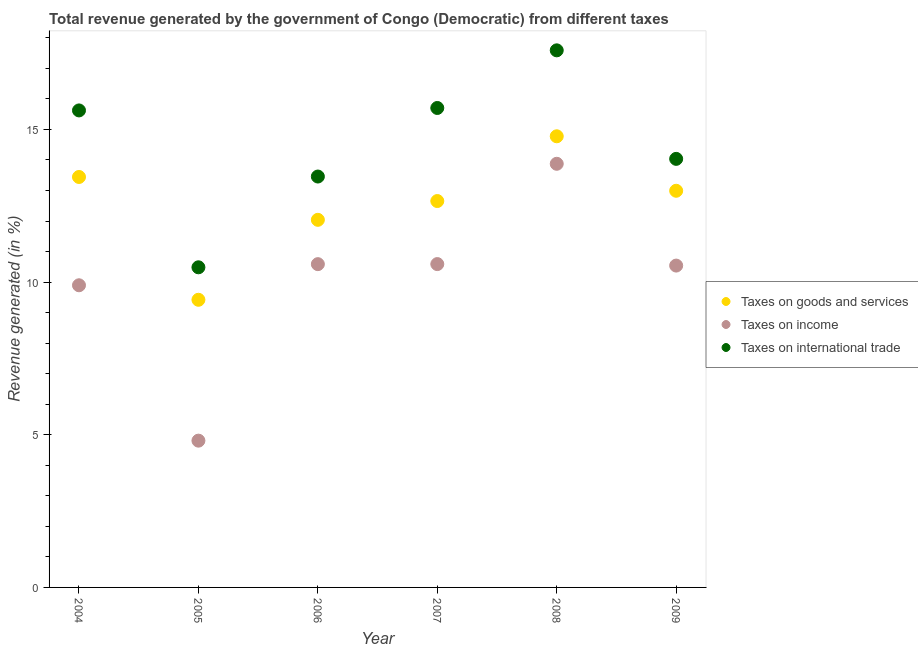What is the percentage of revenue generated by taxes on goods and services in 2009?
Give a very brief answer. 12.99. Across all years, what is the maximum percentage of revenue generated by taxes on goods and services?
Offer a very short reply. 14.78. Across all years, what is the minimum percentage of revenue generated by taxes on income?
Your response must be concise. 4.81. In which year was the percentage of revenue generated by taxes on goods and services maximum?
Offer a very short reply. 2008. In which year was the percentage of revenue generated by tax on international trade minimum?
Give a very brief answer. 2005. What is the total percentage of revenue generated by taxes on income in the graph?
Keep it short and to the point. 60.3. What is the difference between the percentage of revenue generated by taxes on income in 2004 and that in 2005?
Offer a terse response. 5.09. What is the difference between the percentage of revenue generated by taxes on goods and services in 2008 and the percentage of revenue generated by tax on international trade in 2004?
Make the answer very short. -0.85. What is the average percentage of revenue generated by taxes on income per year?
Give a very brief answer. 10.05. In the year 2004, what is the difference between the percentage of revenue generated by taxes on income and percentage of revenue generated by tax on international trade?
Offer a very short reply. -5.73. What is the ratio of the percentage of revenue generated by tax on international trade in 2004 to that in 2009?
Provide a short and direct response. 1.11. Is the percentage of revenue generated by tax on international trade in 2004 less than that in 2008?
Your answer should be very brief. Yes. Is the difference between the percentage of revenue generated by taxes on income in 2005 and 2008 greater than the difference between the percentage of revenue generated by taxes on goods and services in 2005 and 2008?
Your response must be concise. No. What is the difference between the highest and the second highest percentage of revenue generated by tax on international trade?
Your answer should be compact. 1.89. What is the difference between the highest and the lowest percentage of revenue generated by taxes on goods and services?
Provide a short and direct response. 5.35. In how many years, is the percentage of revenue generated by taxes on income greater than the average percentage of revenue generated by taxes on income taken over all years?
Your response must be concise. 4. Is the percentage of revenue generated by taxes on income strictly less than the percentage of revenue generated by taxes on goods and services over the years?
Give a very brief answer. Yes. How many dotlines are there?
Your response must be concise. 3. How many years are there in the graph?
Give a very brief answer. 6. What is the difference between two consecutive major ticks on the Y-axis?
Provide a succinct answer. 5. Are the values on the major ticks of Y-axis written in scientific E-notation?
Your answer should be very brief. No. Does the graph contain any zero values?
Offer a terse response. No. How many legend labels are there?
Offer a terse response. 3. What is the title of the graph?
Your answer should be compact. Total revenue generated by the government of Congo (Democratic) from different taxes. Does "Social Protection and Labor" appear as one of the legend labels in the graph?
Ensure brevity in your answer.  No. What is the label or title of the Y-axis?
Provide a succinct answer. Revenue generated (in %). What is the Revenue generated (in %) in Taxes on goods and services in 2004?
Your answer should be compact. 13.44. What is the Revenue generated (in %) of Taxes on income in 2004?
Give a very brief answer. 9.9. What is the Revenue generated (in %) in Taxes on international trade in 2004?
Provide a succinct answer. 15.62. What is the Revenue generated (in %) of Taxes on goods and services in 2005?
Your response must be concise. 9.42. What is the Revenue generated (in %) in Taxes on income in 2005?
Keep it short and to the point. 4.81. What is the Revenue generated (in %) of Taxes on international trade in 2005?
Provide a short and direct response. 10.48. What is the Revenue generated (in %) in Taxes on goods and services in 2006?
Make the answer very short. 12.04. What is the Revenue generated (in %) in Taxes on income in 2006?
Provide a short and direct response. 10.59. What is the Revenue generated (in %) of Taxes on international trade in 2006?
Ensure brevity in your answer.  13.46. What is the Revenue generated (in %) in Taxes on goods and services in 2007?
Your answer should be compact. 12.66. What is the Revenue generated (in %) in Taxes on income in 2007?
Your answer should be compact. 10.59. What is the Revenue generated (in %) in Taxes on international trade in 2007?
Ensure brevity in your answer.  15.7. What is the Revenue generated (in %) of Taxes on goods and services in 2008?
Ensure brevity in your answer.  14.78. What is the Revenue generated (in %) of Taxes on income in 2008?
Your answer should be very brief. 13.88. What is the Revenue generated (in %) of Taxes on international trade in 2008?
Provide a succinct answer. 17.59. What is the Revenue generated (in %) in Taxes on goods and services in 2009?
Keep it short and to the point. 12.99. What is the Revenue generated (in %) of Taxes on income in 2009?
Offer a terse response. 10.54. What is the Revenue generated (in %) of Taxes on international trade in 2009?
Give a very brief answer. 14.04. Across all years, what is the maximum Revenue generated (in %) of Taxes on goods and services?
Give a very brief answer. 14.78. Across all years, what is the maximum Revenue generated (in %) of Taxes on income?
Offer a terse response. 13.88. Across all years, what is the maximum Revenue generated (in %) in Taxes on international trade?
Your response must be concise. 17.59. Across all years, what is the minimum Revenue generated (in %) of Taxes on goods and services?
Give a very brief answer. 9.42. Across all years, what is the minimum Revenue generated (in %) of Taxes on income?
Your response must be concise. 4.81. Across all years, what is the minimum Revenue generated (in %) in Taxes on international trade?
Offer a very short reply. 10.48. What is the total Revenue generated (in %) of Taxes on goods and services in the graph?
Make the answer very short. 75.33. What is the total Revenue generated (in %) of Taxes on income in the graph?
Your answer should be very brief. 60.3. What is the total Revenue generated (in %) in Taxes on international trade in the graph?
Provide a succinct answer. 86.9. What is the difference between the Revenue generated (in %) in Taxes on goods and services in 2004 and that in 2005?
Make the answer very short. 4.02. What is the difference between the Revenue generated (in %) in Taxes on income in 2004 and that in 2005?
Your answer should be compact. 5.09. What is the difference between the Revenue generated (in %) of Taxes on international trade in 2004 and that in 2005?
Your response must be concise. 5.14. What is the difference between the Revenue generated (in %) in Taxes on goods and services in 2004 and that in 2006?
Your answer should be very brief. 1.4. What is the difference between the Revenue generated (in %) of Taxes on income in 2004 and that in 2006?
Offer a terse response. -0.69. What is the difference between the Revenue generated (in %) of Taxes on international trade in 2004 and that in 2006?
Your response must be concise. 2.17. What is the difference between the Revenue generated (in %) in Taxes on goods and services in 2004 and that in 2007?
Your response must be concise. 0.79. What is the difference between the Revenue generated (in %) of Taxes on income in 2004 and that in 2007?
Keep it short and to the point. -0.69. What is the difference between the Revenue generated (in %) of Taxes on international trade in 2004 and that in 2007?
Provide a succinct answer. -0.08. What is the difference between the Revenue generated (in %) of Taxes on goods and services in 2004 and that in 2008?
Provide a short and direct response. -1.33. What is the difference between the Revenue generated (in %) of Taxes on income in 2004 and that in 2008?
Offer a terse response. -3.98. What is the difference between the Revenue generated (in %) in Taxes on international trade in 2004 and that in 2008?
Keep it short and to the point. -1.97. What is the difference between the Revenue generated (in %) of Taxes on goods and services in 2004 and that in 2009?
Your answer should be very brief. 0.45. What is the difference between the Revenue generated (in %) in Taxes on income in 2004 and that in 2009?
Offer a terse response. -0.64. What is the difference between the Revenue generated (in %) of Taxes on international trade in 2004 and that in 2009?
Your response must be concise. 1.59. What is the difference between the Revenue generated (in %) in Taxes on goods and services in 2005 and that in 2006?
Your answer should be compact. -2.62. What is the difference between the Revenue generated (in %) in Taxes on income in 2005 and that in 2006?
Keep it short and to the point. -5.78. What is the difference between the Revenue generated (in %) of Taxes on international trade in 2005 and that in 2006?
Keep it short and to the point. -2.97. What is the difference between the Revenue generated (in %) in Taxes on goods and services in 2005 and that in 2007?
Provide a succinct answer. -3.23. What is the difference between the Revenue generated (in %) of Taxes on income in 2005 and that in 2007?
Your answer should be very brief. -5.78. What is the difference between the Revenue generated (in %) in Taxes on international trade in 2005 and that in 2007?
Keep it short and to the point. -5.22. What is the difference between the Revenue generated (in %) in Taxes on goods and services in 2005 and that in 2008?
Offer a terse response. -5.35. What is the difference between the Revenue generated (in %) of Taxes on income in 2005 and that in 2008?
Your response must be concise. -9.07. What is the difference between the Revenue generated (in %) of Taxes on international trade in 2005 and that in 2008?
Offer a very short reply. -7.11. What is the difference between the Revenue generated (in %) in Taxes on goods and services in 2005 and that in 2009?
Offer a very short reply. -3.57. What is the difference between the Revenue generated (in %) of Taxes on income in 2005 and that in 2009?
Your answer should be compact. -5.73. What is the difference between the Revenue generated (in %) of Taxes on international trade in 2005 and that in 2009?
Make the answer very short. -3.55. What is the difference between the Revenue generated (in %) of Taxes on goods and services in 2006 and that in 2007?
Give a very brief answer. -0.62. What is the difference between the Revenue generated (in %) in Taxes on income in 2006 and that in 2007?
Offer a very short reply. -0. What is the difference between the Revenue generated (in %) of Taxes on international trade in 2006 and that in 2007?
Provide a succinct answer. -2.25. What is the difference between the Revenue generated (in %) of Taxes on goods and services in 2006 and that in 2008?
Offer a terse response. -2.74. What is the difference between the Revenue generated (in %) in Taxes on income in 2006 and that in 2008?
Your response must be concise. -3.29. What is the difference between the Revenue generated (in %) of Taxes on international trade in 2006 and that in 2008?
Your answer should be compact. -4.13. What is the difference between the Revenue generated (in %) of Taxes on goods and services in 2006 and that in 2009?
Offer a terse response. -0.95. What is the difference between the Revenue generated (in %) of Taxes on income in 2006 and that in 2009?
Offer a terse response. 0.05. What is the difference between the Revenue generated (in %) in Taxes on international trade in 2006 and that in 2009?
Your answer should be compact. -0.58. What is the difference between the Revenue generated (in %) of Taxes on goods and services in 2007 and that in 2008?
Your response must be concise. -2.12. What is the difference between the Revenue generated (in %) in Taxes on income in 2007 and that in 2008?
Give a very brief answer. -3.28. What is the difference between the Revenue generated (in %) in Taxes on international trade in 2007 and that in 2008?
Give a very brief answer. -1.89. What is the difference between the Revenue generated (in %) of Taxes on goods and services in 2007 and that in 2009?
Your answer should be very brief. -0.34. What is the difference between the Revenue generated (in %) of Taxes on income in 2007 and that in 2009?
Give a very brief answer. 0.05. What is the difference between the Revenue generated (in %) in Taxes on international trade in 2007 and that in 2009?
Your answer should be compact. 1.67. What is the difference between the Revenue generated (in %) in Taxes on goods and services in 2008 and that in 2009?
Give a very brief answer. 1.78. What is the difference between the Revenue generated (in %) in Taxes on income in 2008 and that in 2009?
Give a very brief answer. 3.33. What is the difference between the Revenue generated (in %) in Taxes on international trade in 2008 and that in 2009?
Offer a terse response. 3.55. What is the difference between the Revenue generated (in %) in Taxes on goods and services in 2004 and the Revenue generated (in %) in Taxes on income in 2005?
Make the answer very short. 8.64. What is the difference between the Revenue generated (in %) in Taxes on goods and services in 2004 and the Revenue generated (in %) in Taxes on international trade in 2005?
Ensure brevity in your answer.  2.96. What is the difference between the Revenue generated (in %) in Taxes on income in 2004 and the Revenue generated (in %) in Taxes on international trade in 2005?
Ensure brevity in your answer.  -0.59. What is the difference between the Revenue generated (in %) in Taxes on goods and services in 2004 and the Revenue generated (in %) in Taxes on income in 2006?
Your response must be concise. 2.86. What is the difference between the Revenue generated (in %) of Taxes on goods and services in 2004 and the Revenue generated (in %) of Taxes on international trade in 2006?
Your answer should be very brief. -0.01. What is the difference between the Revenue generated (in %) of Taxes on income in 2004 and the Revenue generated (in %) of Taxes on international trade in 2006?
Give a very brief answer. -3.56. What is the difference between the Revenue generated (in %) of Taxes on goods and services in 2004 and the Revenue generated (in %) of Taxes on income in 2007?
Ensure brevity in your answer.  2.85. What is the difference between the Revenue generated (in %) in Taxes on goods and services in 2004 and the Revenue generated (in %) in Taxes on international trade in 2007?
Offer a very short reply. -2.26. What is the difference between the Revenue generated (in %) in Taxes on income in 2004 and the Revenue generated (in %) in Taxes on international trade in 2007?
Ensure brevity in your answer.  -5.81. What is the difference between the Revenue generated (in %) in Taxes on goods and services in 2004 and the Revenue generated (in %) in Taxes on income in 2008?
Give a very brief answer. -0.43. What is the difference between the Revenue generated (in %) of Taxes on goods and services in 2004 and the Revenue generated (in %) of Taxes on international trade in 2008?
Provide a succinct answer. -4.15. What is the difference between the Revenue generated (in %) in Taxes on income in 2004 and the Revenue generated (in %) in Taxes on international trade in 2008?
Make the answer very short. -7.69. What is the difference between the Revenue generated (in %) in Taxes on goods and services in 2004 and the Revenue generated (in %) in Taxes on income in 2009?
Provide a short and direct response. 2.9. What is the difference between the Revenue generated (in %) in Taxes on goods and services in 2004 and the Revenue generated (in %) in Taxes on international trade in 2009?
Your answer should be compact. -0.59. What is the difference between the Revenue generated (in %) of Taxes on income in 2004 and the Revenue generated (in %) of Taxes on international trade in 2009?
Provide a succinct answer. -4.14. What is the difference between the Revenue generated (in %) in Taxes on goods and services in 2005 and the Revenue generated (in %) in Taxes on income in 2006?
Provide a short and direct response. -1.17. What is the difference between the Revenue generated (in %) of Taxes on goods and services in 2005 and the Revenue generated (in %) of Taxes on international trade in 2006?
Offer a terse response. -4.04. What is the difference between the Revenue generated (in %) of Taxes on income in 2005 and the Revenue generated (in %) of Taxes on international trade in 2006?
Provide a short and direct response. -8.65. What is the difference between the Revenue generated (in %) of Taxes on goods and services in 2005 and the Revenue generated (in %) of Taxes on income in 2007?
Offer a very short reply. -1.17. What is the difference between the Revenue generated (in %) of Taxes on goods and services in 2005 and the Revenue generated (in %) of Taxes on international trade in 2007?
Your response must be concise. -6.28. What is the difference between the Revenue generated (in %) in Taxes on income in 2005 and the Revenue generated (in %) in Taxes on international trade in 2007?
Keep it short and to the point. -10.9. What is the difference between the Revenue generated (in %) of Taxes on goods and services in 2005 and the Revenue generated (in %) of Taxes on income in 2008?
Provide a short and direct response. -4.45. What is the difference between the Revenue generated (in %) of Taxes on goods and services in 2005 and the Revenue generated (in %) of Taxes on international trade in 2008?
Offer a terse response. -8.17. What is the difference between the Revenue generated (in %) of Taxes on income in 2005 and the Revenue generated (in %) of Taxes on international trade in 2008?
Make the answer very short. -12.78. What is the difference between the Revenue generated (in %) in Taxes on goods and services in 2005 and the Revenue generated (in %) in Taxes on income in 2009?
Provide a short and direct response. -1.12. What is the difference between the Revenue generated (in %) of Taxes on goods and services in 2005 and the Revenue generated (in %) of Taxes on international trade in 2009?
Your response must be concise. -4.62. What is the difference between the Revenue generated (in %) of Taxes on income in 2005 and the Revenue generated (in %) of Taxes on international trade in 2009?
Keep it short and to the point. -9.23. What is the difference between the Revenue generated (in %) in Taxes on goods and services in 2006 and the Revenue generated (in %) in Taxes on income in 2007?
Offer a very short reply. 1.45. What is the difference between the Revenue generated (in %) of Taxes on goods and services in 2006 and the Revenue generated (in %) of Taxes on international trade in 2007?
Offer a terse response. -3.66. What is the difference between the Revenue generated (in %) in Taxes on income in 2006 and the Revenue generated (in %) in Taxes on international trade in 2007?
Keep it short and to the point. -5.11. What is the difference between the Revenue generated (in %) in Taxes on goods and services in 2006 and the Revenue generated (in %) in Taxes on income in 2008?
Make the answer very short. -1.84. What is the difference between the Revenue generated (in %) in Taxes on goods and services in 2006 and the Revenue generated (in %) in Taxes on international trade in 2008?
Your answer should be compact. -5.55. What is the difference between the Revenue generated (in %) of Taxes on income in 2006 and the Revenue generated (in %) of Taxes on international trade in 2008?
Your answer should be very brief. -7. What is the difference between the Revenue generated (in %) in Taxes on goods and services in 2006 and the Revenue generated (in %) in Taxes on income in 2009?
Offer a terse response. 1.5. What is the difference between the Revenue generated (in %) of Taxes on goods and services in 2006 and the Revenue generated (in %) of Taxes on international trade in 2009?
Make the answer very short. -2. What is the difference between the Revenue generated (in %) of Taxes on income in 2006 and the Revenue generated (in %) of Taxes on international trade in 2009?
Keep it short and to the point. -3.45. What is the difference between the Revenue generated (in %) of Taxes on goods and services in 2007 and the Revenue generated (in %) of Taxes on income in 2008?
Ensure brevity in your answer.  -1.22. What is the difference between the Revenue generated (in %) of Taxes on goods and services in 2007 and the Revenue generated (in %) of Taxes on international trade in 2008?
Offer a terse response. -4.94. What is the difference between the Revenue generated (in %) in Taxes on income in 2007 and the Revenue generated (in %) in Taxes on international trade in 2008?
Your answer should be compact. -7. What is the difference between the Revenue generated (in %) of Taxes on goods and services in 2007 and the Revenue generated (in %) of Taxes on income in 2009?
Provide a succinct answer. 2.11. What is the difference between the Revenue generated (in %) of Taxes on goods and services in 2007 and the Revenue generated (in %) of Taxes on international trade in 2009?
Your response must be concise. -1.38. What is the difference between the Revenue generated (in %) in Taxes on income in 2007 and the Revenue generated (in %) in Taxes on international trade in 2009?
Your response must be concise. -3.45. What is the difference between the Revenue generated (in %) of Taxes on goods and services in 2008 and the Revenue generated (in %) of Taxes on income in 2009?
Your answer should be compact. 4.23. What is the difference between the Revenue generated (in %) of Taxes on goods and services in 2008 and the Revenue generated (in %) of Taxes on international trade in 2009?
Your answer should be compact. 0.74. What is the difference between the Revenue generated (in %) of Taxes on income in 2008 and the Revenue generated (in %) of Taxes on international trade in 2009?
Offer a very short reply. -0.16. What is the average Revenue generated (in %) in Taxes on goods and services per year?
Your answer should be compact. 12.55. What is the average Revenue generated (in %) in Taxes on income per year?
Your answer should be very brief. 10.05. What is the average Revenue generated (in %) of Taxes on international trade per year?
Your answer should be compact. 14.48. In the year 2004, what is the difference between the Revenue generated (in %) in Taxes on goods and services and Revenue generated (in %) in Taxes on income?
Your answer should be very brief. 3.55. In the year 2004, what is the difference between the Revenue generated (in %) in Taxes on goods and services and Revenue generated (in %) in Taxes on international trade?
Give a very brief answer. -2.18. In the year 2004, what is the difference between the Revenue generated (in %) in Taxes on income and Revenue generated (in %) in Taxes on international trade?
Offer a terse response. -5.73. In the year 2005, what is the difference between the Revenue generated (in %) of Taxes on goods and services and Revenue generated (in %) of Taxes on income?
Offer a terse response. 4.61. In the year 2005, what is the difference between the Revenue generated (in %) in Taxes on goods and services and Revenue generated (in %) in Taxes on international trade?
Provide a succinct answer. -1.06. In the year 2005, what is the difference between the Revenue generated (in %) in Taxes on income and Revenue generated (in %) in Taxes on international trade?
Give a very brief answer. -5.68. In the year 2006, what is the difference between the Revenue generated (in %) of Taxes on goods and services and Revenue generated (in %) of Taxes on income?
Your answer should be very brief. 1.45. In the year 2006, what is the difference between the Revenue generated (in %) of Taxes on goods and services and Revenue generated (in %) of Taxes on international trade?
Keep it short and to the point. -1.42. In the year 2006, what is the difference between the Revenue generated (in %) of Taxes on income and Revenue generated (in %) of Taxes on international trade?
Your response must be concise. -2.87. In the year 2007, what is the difference between the Revenue generated (in %) of Taxes on goods and services and Revenue generated (in %) of Taxes on income?
Your answer should be compact. 2.06. In the year 2007, what is the difference between the Revenue generated (in %) of Taxes on goods and services and Revenue generated (in %) of Taxes on international trade?
Keep it short and to the point. -3.05. In the year 2007, what is the difference between the Revenue generated (in %) in Taxes on income and Revenue generated (in %) in Taxes on international trade?
Make the answer very short. -5.11. In the year 2008, what is the difference between the Revenue generated (in %) of Taxes on goods and services and Revenue generated (in %) of Taxes on income?
Offer a terse response. 0.9. In the year 2008, what is the difference between the Revenue generated (in %) in Taxes on goods and services and Revenue generated (in %) in Taxes on international trade?
Ensure brevity in your answer.  -2.81. In the year 2008, what is the difference between the Revenue generated (in %) in Taxes on income and Revenue generated (in %) in Taxes on international trade?
Ensure brevity in your answer.  -3.72. In the year 2009, what is the difference between the Revenue generated (in %) in Taxes on goods and services and Revenue generated (in %) in Taxes on income?
Provide a short and direct response. 2.45. In the year 2009, what is the difference between the Revenue generated (in %) of Taxes on goods and services and Revenue generated (in %) of Taxes on international trade?
Your response must be concise. -1.05. In the year 2009, what is the difference between the Revenue generated (in %) in Taxes on income and Revenue generated (in %) in Taxes on international trade?
Keep it short and to the point. -3.5. What is the ratio of the Revenue generated (in %) in Taxes on goods and services in 2004 to that in 2005?
Your response must be concise. 1.43. What is the ratio of the Revenue generated (in %) of Taxes on income in 2004 to that in 2005?
Make the answer very short. 2.06. What is the ratio of the Revenue generated (in %) in Taxes on international trade in 2004 to that in 2005?
Provide a short and direct response. 1.49. What is the ratio of the Revenue generated (in %) in Taxes on goods and services in 2004 to that in 2006?
Offer a very short reply. 1.12. What is the ratio of the Revenue generated (in %) in Taxes on income in 2004 to that in 2006?
Keep it short and to the point. 0.93. What is the ratio of the Revenue generated (in %) in Taxes on international trade in 2004 to that in 2006?
Your response must be concise. 1.16. What is the ratio of the Revenue generated (in %) of Taxes on goods and services in 2004 to that in 2007?
Your answer should be very brief. 1.06. What is the ratio of the Revenue generated (in %) of Taxes on income in 2004 to that in 2007?
Offer a terse response. 0.93. What is the ratio of the Revenue generated (in %) in Taxes on international trade in 2004 to that in 2007?
Provide a succinct answer. 0.99. What is the ratio of the Revenue generated (in %) of Taxes on goods and services in 2004 to that in 2008?
Provide a short and direct response. 0.91. What is the ratio of the Revenue generated (in %) of Taxes on income in 2004 to that in 2008?
Provide a short and direct response. 0.71. What is the ratio of the Revenue generated (in %) in Taxes on international trade in 2004 to that in 2008?
Make the answer very short. 0.89. What is the ratio of the Revenue generated (in %) of Taxes on goods and services in 2004 to that in 2009?
Offer a terse response. 1.03. What is the ratio of the Revenue generated (in %) in Taxes on income in 2004 to that in 2009?
Keep it short and to the point. 0.94. What is the ratio of the Revenue generated (in %) in Taxes on international trade in 2004 to that in 2009?
Your answer should be compact. 1.11. What is the ratio of the Revenue generated (in %) of Taxes on goods and services in 2005 to that in 2006?
Make the answer very short. 0.78. What is the ratio of the Revenue generated (in %) of Taxes on income in 2005 to that in 2006?
Ensure brevity in your answer.  0.45. What is the ratio of the Revenue generated (in %) in Taxes on international trade in 2005 to that in 2006?
Your answer should be compact. 0.78. What is the ratio of the Revenue generated (in %) in Taxes on goods and services in 2005 to that in 2007?
Offer a very short reply. 0.74. What is the ratio of the Revenue generated (in %) in Taxes on income in 2005 to that in 2007?
Ensure brevity in your answer.  0.45. What is the ratio of the Revenue generated (in %) of Taxes on international trade in 2005 to that in 2007?
Your response must be concise. 0.67. What is the ratio of the Revenue generated (in %) in Taxes on goods and services in 2005 to that in 2008?
Offer a terse response. 0.64. What is the ratio of the Revenue generated (in %) of Taxes on income in 2005 to that in 2008?
Ensure brevity in your answer.  0.35. What is the ratio of the Revenue generated (in %) of Taxes on international trade in 2005 to that in 2008?
Give a very brief answer. 0.6. What is the ratio of the Revenue generated (in %) of Taxes on goods and services in 2005 to that in 2009?
Provide a succinct answer. 0.73. What is the ratio of the Revenue generated (in %) in Taxes on income in 2005 to that in 2009?
Provide a short and direct response. 0.46. What is the ratio of the Revenue generated (in %) in Taxes on international trade in 2005 to that in 2009?
Ensure brevity in your answer.  0.75. What is the ratio of the Revenue generated (in %) in Taxes on goods and services in 2006 to that in 2007?
Your response must be concise. 0.95. What is the ratio of the Revenue generated (in %) in Taxes on international trade in 2006 to that in 2007?
Offer a very short reply. 0.86. What is the ratio of the Revenue generated (in %) of Taxes on goods and services in 2006 to that in 2008?
Your response must be concise. 0.81. What is the ratio of the Revenue generated (in %) of Taxes on income in 2006 to that in 2008?
Your answer should be compact. 0.76. What is the ratio of the Revenue generated (in %) of Taxes on international trade in 2006 to that in 2008?
Offer a very short reply. 0.77. What is the ratio of the Revenue generated (in %) of Taxes on goods and services in 2006 to that in 2009?
Offer a terse response. 0.93. What is the ratio of the Revenue generated (in %) of Taxes on income in 2006 to that in 2009?
Ensure brevity in your answer.  1. What is the ratio of the Revenue generated (in %) in Taxes on international trade in 2006 to that in 2009?
Your response must be concise. 0.96. What is the ratio of the Revenue generated (in %) in Taxes on goods and services in 2007 to that in 2008?
Your response must be concise. 0.86. What is the ratio of the Revenue generated (in %) of Taxes on income in 2007 to that in 2008?
Provide a short and direct response. 0.76. What is the ratio of the Revenue generated (in %) of Taxes on international trade in 2007 to that in 2008?
Your answer should be very brief. 0.89. What is the ratio of the Revenue generated (in %) of Taxes on goods and services in 2007 to that in 2009?
Ensure brevity in your answer.  0.97. What is the ratio of the Revenue generated (in %) of Taxes on income in 2007 to that in 2009?
Make the answer very short. 1. What is the ratio of the Revenue generated (in %) in Taxes on international trade in 2007 to that in 2009?
Your answer should be very brief. 1.12. What is the ratio of the Revenue generated (in %) of Taxes on goods and services in 2008 to that in 2009?
Give a very brief answer. 1.14. What is the ratio of the Revenue generated (in %) in Taxes on income in 2008 to that in 2009?
Give a very brief answer. 1.32. What is the ratio of the Revenue generated (in %) of Taxes on international trade in 2008 to that in 2009?
Offer a terse response. 1.25. What is the difference between the highest and the second highest Revenue generated (in %) of Taxes on goods and services?
Provide a short and direct response. 1.33. What is the difference between the highest and the second highest Revenue generated (in %) of Taxes on income?
Provide a succinct answer. 3.28. What is the difference between the highest and the second highest Revenue generated (in %) in Taxes on international trade?
Provide a succinct answer. 1.89. What is the difference between the highest and the lowest Revenue generated (in %) in Taxes on goods and services?
Offer a terse response. 5.35. What is the difference between the highest and the lowest Revenue generated (in %) of Taxes on income?
Your response must be concise. 9.07. What is the difference between the highest and the lowest Revenue generated (in %) of Taxes on international trade?
Your answer should be very brief. 7.11. 